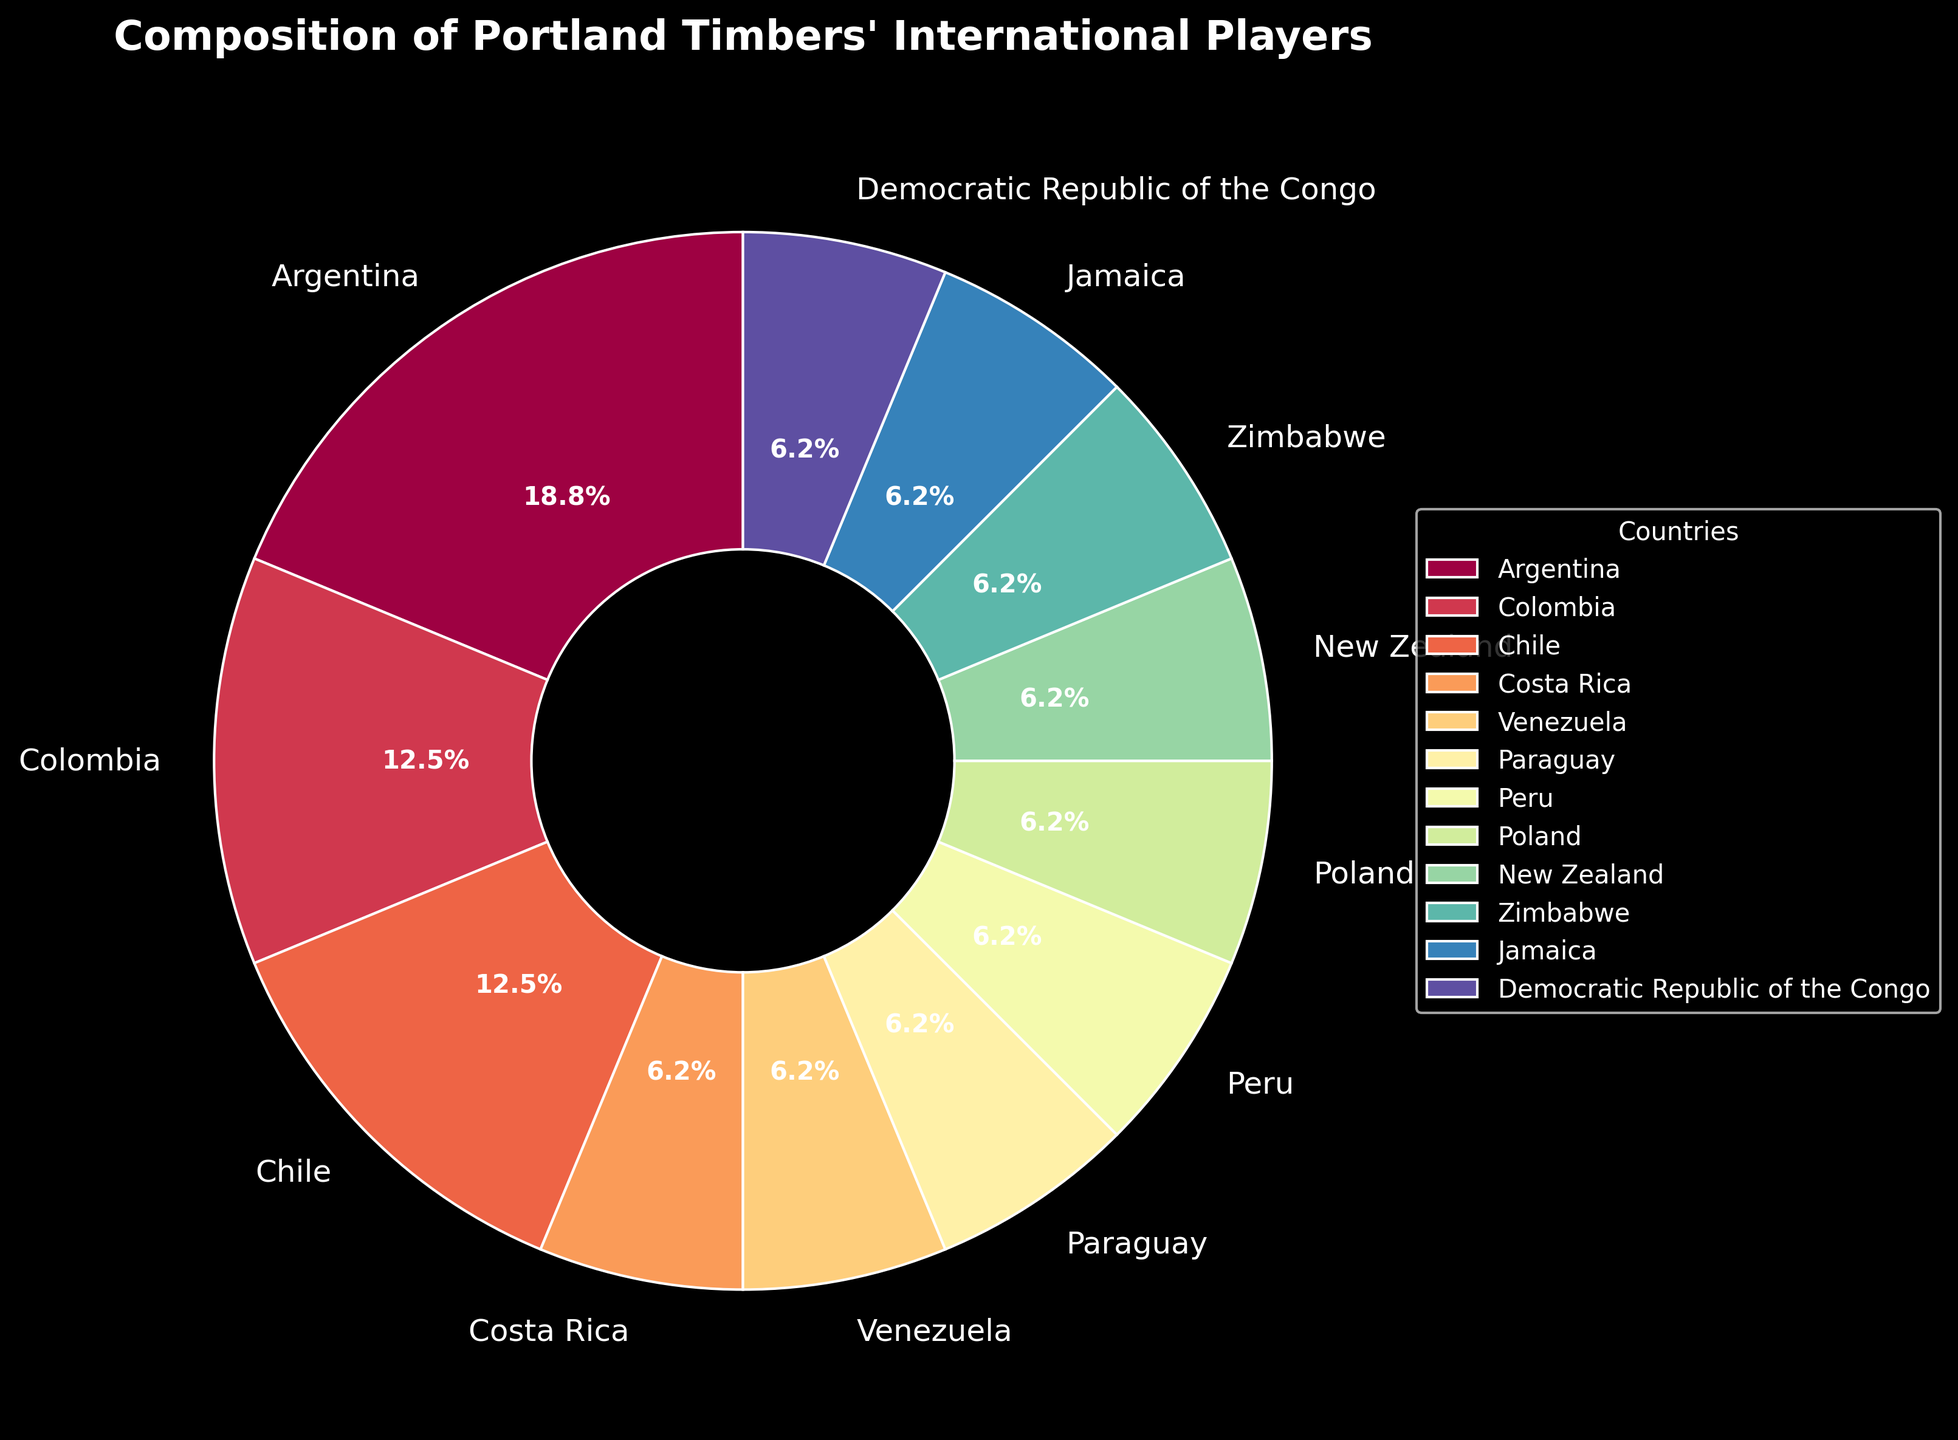What percentage of the Portland Timbers' international players come from Argentina? In the pie chart, we see that Argentina contributes 3 players. To calculate the percentage, use the formula (Number of Players from Argentina / Total Number of International Players) × 100. The total number of international players is 16. Thus, (3/16) × 100 ≈ 18.75%.
Answer: 18.75% How many South American countries are represented in the Portland Timbers' international player composition? In the figure, Argentina, Colombia, Chile, Venezuela, Paraguay, and Peru are South American countries. Count the number of these countries: 6.
Answer: 6 Which country has the most international players in the figure? By looking at the pie chart, Argentina has the largest segment with 3 players.
Answer: Argentina Are there more players from Africa or Europe in the Portland Timbers' international player composition? From the pie chart, the African countries represented are Zimbabwe and the Democratic Republic of the Congo, each with 1 player. The European country represented is Poland, with 1 player. Therefore, 2 players are from Africa and 1 from Europe.
Answer: Africa What proportion of international players comes from countries with only one player each? Sum the number of players from countries with only one representative: Costa Rica (1), Venezuela (1), Paraguay (1), Peru (1), Poland (1), New Zealand (1), Zimbabwe (1), Jamaica (1), Democratic Republic of the Congo (1), which totals 9 players. The total number of international players is 16. Thus, the proportion is 9/16.
Answer: 0.5625 What is the ratio of players from South America to players from North America in the data? The South American countries are Argentina (3), Colombia (2), Chile (2), Venezuela (1), Paraguay (1), Peru (1), summing to 10 players. The North American country is Costa Rica with 1 player. Hence, the ratio is 10:1.
Answer: 10:1 Which two countries together account for the highest percentage of international players? The two largest segments in the pie chart are Argentina (3 players) and Colombia (2 players). Together they account for 3+2=5 out of 16 players. The percentage is (5/16) × 100 ≈ 31.25%.
Answer: Argentina and Colombia How many continents are represented by the Portland Timbers' international players based on the countries listed? The continents represented are South America, North America, Europe, Oceania, and Africa. This counts to 5 continents.
Answer: 5 